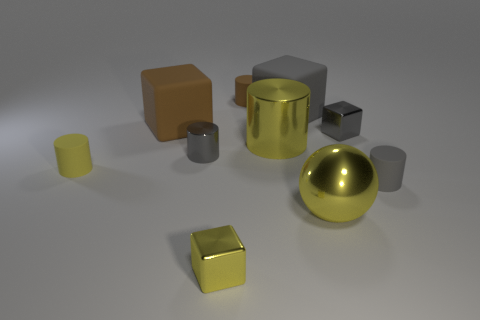What is the tiny yellow thing to the left of the small gray shiny cylinder made of?
Provide a short and direct response. Rubber. Is the size of the gray cube behind the small gray shiny block the same as the yellow metal thing left of the yellow metal cylinder?
Offer a terse response. No. The big cylinder has what color?
Your answer should be compact. Yellow. There is a big matte object that is right of the small brown rubber cylinder; does it have the same shape as the tiny yellow matte thing?
Your response must be concise. No. What is the material of the small brown thing?
Offer a very short reply. Rubber. There is a gray object that is the same size as the shiny sphere; what is its shape?
Provide a short and direct response. Cube. Is there a tiny shiny cylinder of the same color as the big ball?
Provide a short and direct response. No. There is a metallic ball; does it have the same color as the metallic thing that is on the right side of the big yellow metallic sphere?
Keep it short and to the point. No. There is a big metal thing that is in front of the small gray metallic cylinder that is behind the metallic ball; what color is it?
Provide a short and direct response. Yellow. There is a tiny block that is left of the matte cylinder behind the big brown matte thing; are there any big brown objects in front of it?
Offer a terse response. No. 